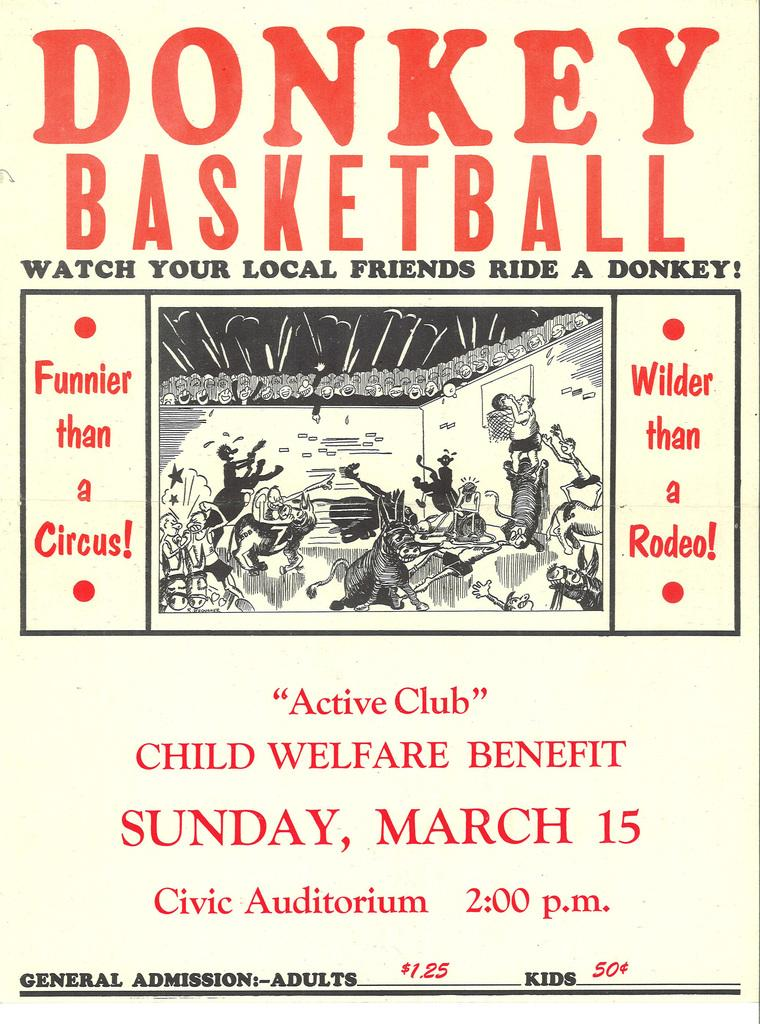What is the main subject of the advertisement in the image? The main subject of the advertisement in the image is basketball. How many twigs are used to create the basketball court in the image? There are no twigs present in the image, as it is an advertisement about basketball. 